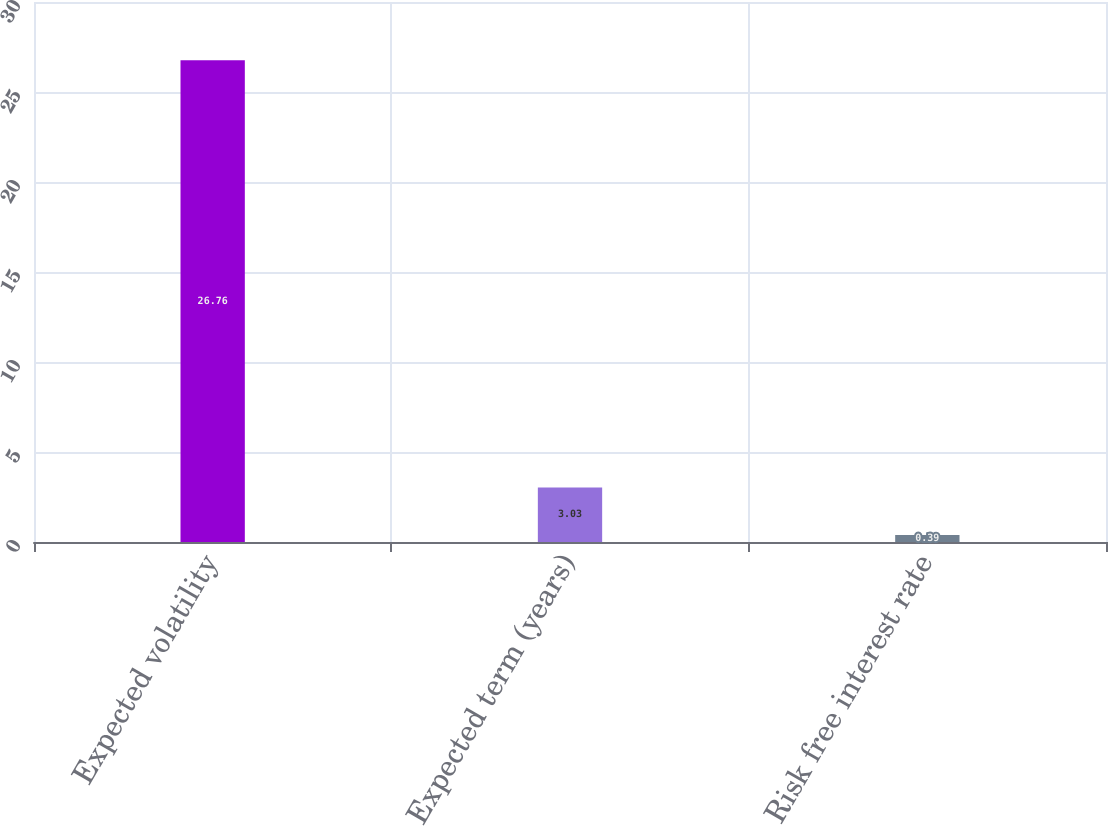Convert chart to OTSL. <chart><loc_0><loc_0><loc_500><loc_500><bar_chart><fcel>Expected volatility<fcel>Expected term (years)<fcel>Risk free interest rate<nl><fcel>26.76<fcel>3.03<fcel>0.39<nl></chart> 